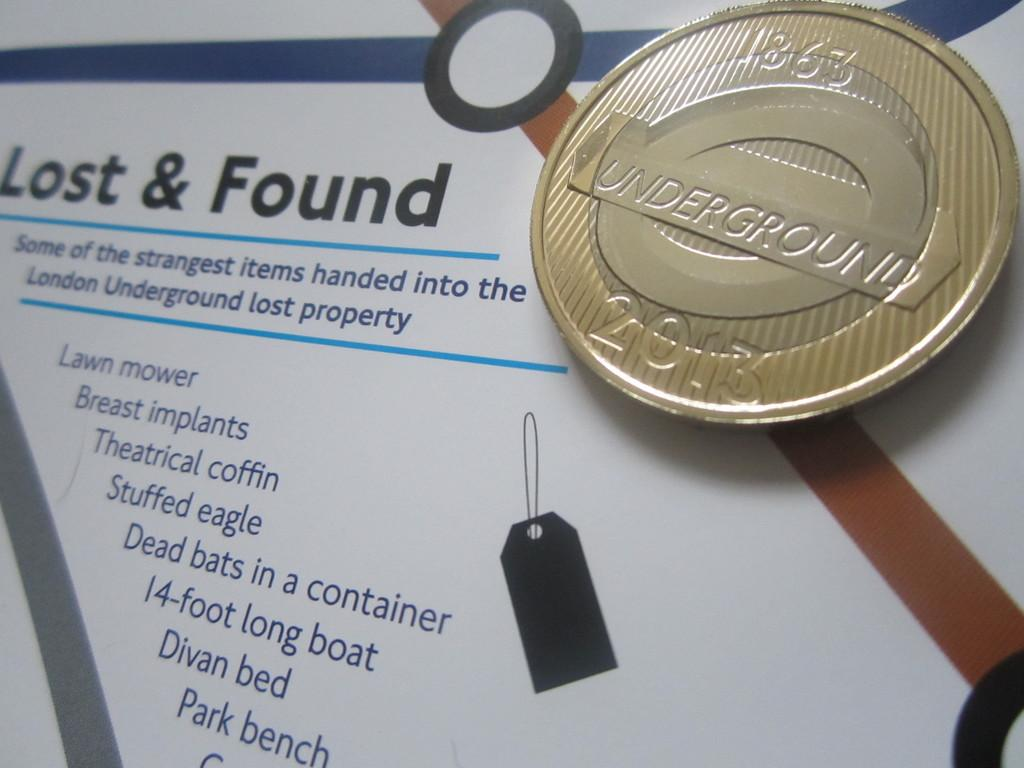<image>
Share a concise interpretation of the image provided. A medallion that says underground is sitting on a lost and found flyer. 